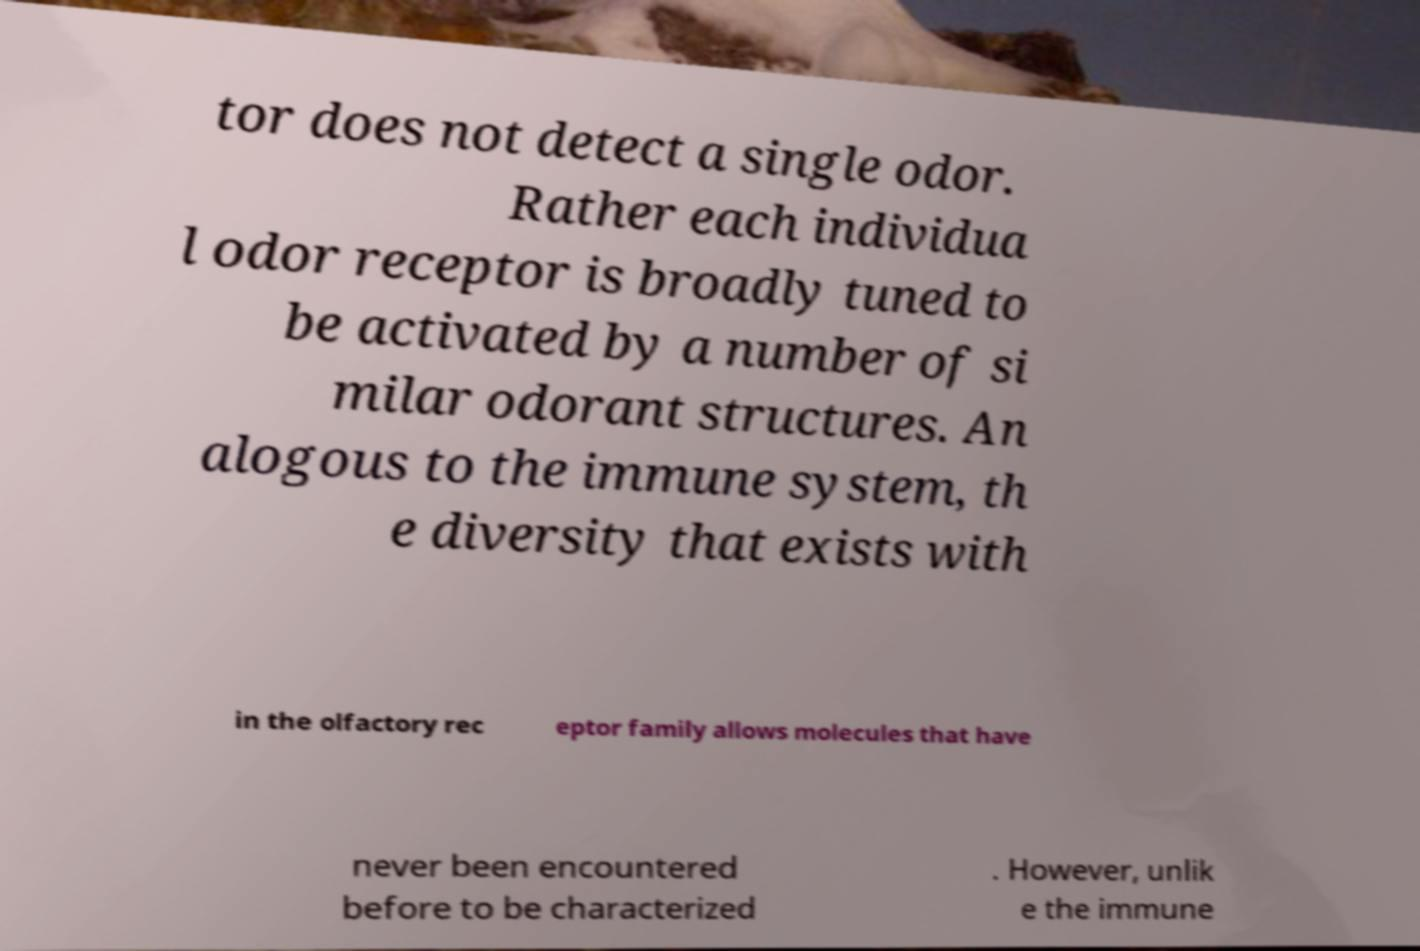Could you assist in decoding the text presented in this image and type it out clearly? tor does not detect a single odor. Rather each individua l odor receptor is broadly tuned to be activated by a number of si milar odorant structures. An alogous to the immune system, th e diversity that exists with in the olfactory rec eptor family allows molecules that have never been encountered before to be characterized . However, unlik e the immune 